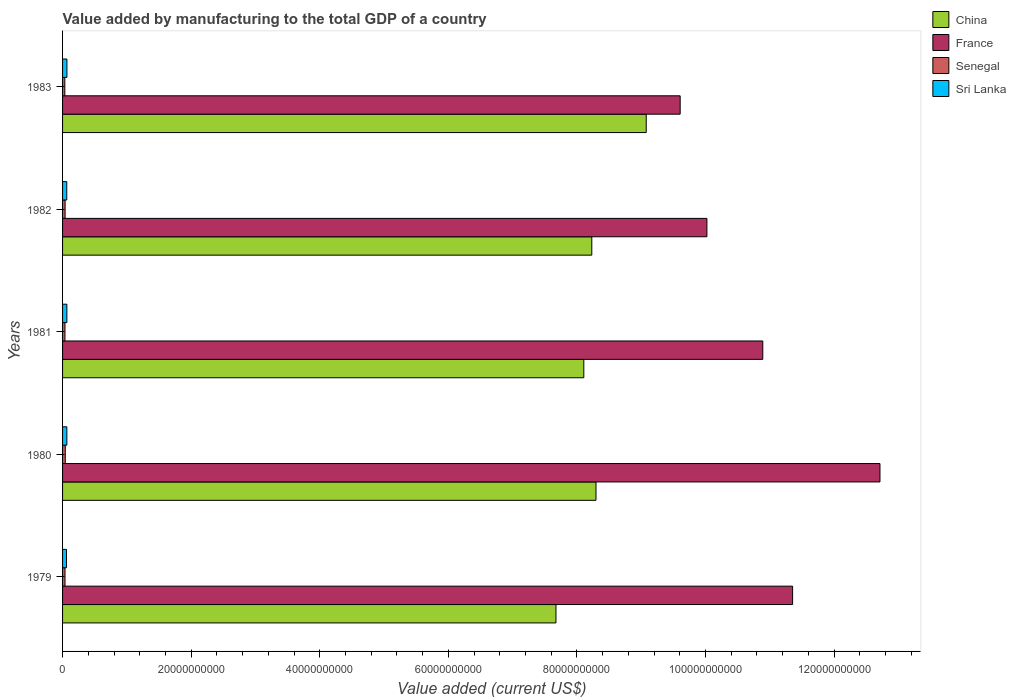How many different coloured bars are there?
Provide a short and direct response. 4. How many groups of bars are there?
Your answer should be very brief. 5. Are the number of bars per tick equal to the number of legend labels?
Make the answer very short. Yes. Are the number of bars on each tick of the Y-axis equal?
Your response must be concise. Yes. How many bars are there on the 5th tick from the top?
Offer a terse response. 4. How many bars are there on the 1st tick from the bottom?
Keep it short and to the point. 4. What is the label of the 2nd group of bars from the top?
Provide a short and direct response. 1982. What is the value added by manufacturing to the total GDP in Senegal in 1981?
Provide a succinct answer. 3.73e+08. Across all years, what is the maximum value added by manufacturing to the total GDP in Sri Lanka?
Ensure brevity in your answer.  6.78e+08. Across all years, what is the minimum value added by manufacturing to the total GDP in Senegal?
Your answer should be compact. 3.51e+08. In which year was the value added by manufacturing to the total GDP in France maximum?
Make the answer very short. 1980. What is the total value added by manufacturing to the total GDP in Sri Lanka in the graph?
Your answer should be compact. 3.28e+09. What is the difference between the value added by manufacturing to the total GDP in Senegal in 1979 and that in 1983?
Your response must be concise. 3.02e+07. What is the difference between the value added by manufacturing to the total GDP in Senegal in 1981 and the value added by manufacturing to the total GDP in France in 1980?
Make the answer very short. -1.27e+11. What is the average value added by manufacturing to the total GDP in Sri Lanka per year?
Give a very brief answer. 6.56e+08. In the year 1980, what is the difference between the value added by manufacturing to the total GDP in Sri Lanka and value added by manufacturing to the total GDP in France?
Give a very brief answer. -1.26e+11. What is the ratio of the value added by manufacturing to the total GDP in Sri Lanka in 1979 to that in 1983?
Your response must be concise. 0.9. Is the difference between the value added by manufacturing to the total GDP in Sri Lanka in 1980 and 1981 greater than the difference between the value added by manufacturing to the total GDP in France in 1980 and 1981?
Keep it short and to the point. No. What is the difference between the highest and the second highest value added by manufacturing to the total GDP in Senegal?
Ensure brevity in your answer.  2.80e+07. What is the difference between the highest and the lowest value added by manufacturing to the total GDP in France?
Your answer should be compact. 3.11e+1. In how many years, is the value added by manufacturing to the total GDP in Senegal greater than the average value added by manufacturing to the total GDP in Senegal taken over all years?
Your answer should be compact. 2. What does the 4th bar from the bottom in 1981 represents?
Provide a succinct answer. Sri Lanka. How many bars are there?
Your answer should be compact. 20. Does the graph contain any zero values?
Provide a short and direct response. No. How are the legend labels stacked?
Keep it short and to the point. Vertical. What is the title of the graph?
Your answer should be compact. Value added by manufacturing to the total GDP of a country. Does "France" appear as one of the legend labels in the graph?
Keep it short and to the point. Yes. What is the label or title of the X-axis?
Offer a terse response. Value added (current US$). What is the label or title of the Y-axis?
Your answer should be very brief. Years. What is the Value added (current US$) in China in 1979?
Offer a very short reply. 7.67e+1. What is the Value added (current US$) in France in 1979?
Offer a terse response. 1.14e+11. What is the Value added (current US$) in Senegal in 1979?
Your response must be concise. 3.81e+08. What is the Value added (current US$) of Sri Lanka in 1979?
Offer a very short reply. 6.09e+08. What is the Value added (current US$) in China in 1980?
Ensure brevity in your answer.  8.30e+1. What is the Value added (current US$) in France in 1980?
Provide a short and direct response. 1.27e+11. What is the Value added (current US$) in Senegal in 1980?
Provide a short and direct response. 4.21e+08. What is the Value added (current US$) in Sri Lanka in 1980?
Ensure brevity in your answer.  6.68e+08. What is the Value added (current US$) in China in 1981?
Provide a short and direct response. 8.11e+1. What is the Value added (current US$) in France in 1981?
Offer a very short reply. 1.09e+11. What is the Value added (current US$) of Senegal in 1981?
Give a very brief answer. 3.73e+08. What is the Value added (current US$) in Sri Lanka in 1981?
Your answer should be very brief. 6.69e+08. What is the Value added (current US$) of China in 1982?
Your response must be concise. 8.23e+1. What is the Value added (current US$) in France in 1982?
Your answer should be very brief. 1.00e+11. What is the Value added (current US$) of Senegal in 1982?
Your response must be concise. 3.93e+08. What is the Value added (current US$) of Sri Lanka in 1982?
Provide a short and direct response. 6.54e+08. What is the Value added (current US$) of China in 1983?
Ensure brevity in your answer.  9.08e+1. What is the Value added (current US$) in France in 1983?
Provide a succinct answer. 9.61e+1. What is the Value added (current US$) in Senegal in 1983?
Give a very brief answer. 3.51e+08. What is the Value added (current US$) in Sri Lanka in 1983?
Ensure brevity in your answer.  6.78e+08. Across all years, what is the maximum Value added (current US$) in China?
Offer a very short reply. 9.08e+1. Across all years, what is the maximum Value added (current US$) of France?
Give a very brief answer. 1.27e+11. Across all years, what is the maximum Value added (current US$) of Senegal?
Your answer should be very brief. 4.21e+08. Across all years, what is the maximum Value added (current US$) in Sri Lanka?
Give a very brief answer. 6.78e+08. Across all years, what is the minimum Value added (current US$) in China?
Your response must be concise. 7.67e+1. Across all years, what is the minimum Value added (current US$) in France?
Provide a succinct answer. 9.61e+1. Across all years, what is the minimum Value added (current US$) in Senegal?
Provide a succinct answer. 3.51e+08. Across all years, what is the minimum Value added (current US$) of Sri Lanka?
Make the answer very short. 6.09e+08. What is the total Value added (current US$) of China in the graph?
Provide a succinct answer. 4.14e+11. What is the total Value added (current US$) of France in the graph?
Your answer should be very brief. 5.46e+11. What is the total Value added (current US$) of Senegal in the graph?
Your answer should be very brief. 1.92e+09. What is the total Value added (current US$) of Sri Lanka in the graph?
Make the answer very short. 3.28e+09. What is the difference between the Value added (current US$) of China in 1979 and that in 1980?
Provide a short and direct response. -6.23e+09. What is the difference between the Value added (current US$) in France in 1979 and that in 1980?
Your answer should be very brief. -1.36e+1. What is the difference between the Value added (current US$) in Senegal in 1979 and that in 1980?
Make the answer very short. -4.01e+07. What is the difference between the Value added (current US$) of Sri Lanka in 1979 and that in 1980?
Offer a very short reply. -5.92e+07. What is the difference between the Value added (current US$) in China in 1979 and that in 1981?
Keep it short and to the point. -4.33e+09. What is the difference between the Value added (current US$) of France in 1979 and that in 1981?
Your answer should be very brief. 4.64e+09. What is the difference between the Value added (current US$) in Senegal in 1979 and that in 1981?
Give a very brief answer. 8.11e+06. What is the difference between the Value added (current US$) of Sri Lanka in 1979 and that in 1981?
Offer a very short reply. -6.01e+07. What is the difference between the Value added (current US$) of China in 1979 and that in 1982?
Offer a terse response. -5.57e+09. What is the difference between the Value added (current US$) in France in 1979 and that in 1982?
Offer a very short reply. 1.33e+1. What is the difference between the Value added (current US$) in Senegal in 1979 and that in 1982?
Make the answer very short. -1.21e+07. What is the difference between the Value added (current US$) of Sri Lanka in 1979 and that in 1982?
Ensure brevity in your answer.  -4.45e+07. What is the difference between the Value added (current US$) of China in 1979 and that in 1983?
Provide a short and direct response. -1.40e+1. What is the difference between the Value added (current US$) of France in 1979 and that in 1983?
Your answer should be compact. 1.75e+1. What is the difference between the Value added (current US$) in Senegal in 1979 and that in 1983?
Give a very brief answer. 3.02e+07. What is the difference between the Value added (current US$) in Sri Lanka in 1979 and that in 1983?
Give a very brief answer. -6.91e+07. What is the difference between the Value added (current US$) in China in 1980 and that in 1981?
Keep it short and to the point. 1.90e+09. What is the difference between the Value added (current US$) in France in 1980 and that in 1981?
Your response must be concise. 1.82e+1. What is the difference between the Value added (current US$) in Senegal in 1980 and that in 1981?
Offer a terse response. 4.82e+07. What is the difference between the Value added (current US$) in Sri Lanka in 1980 and that in 1981?
Your answer should be very brief. -8.86e+05. What is the difference between the Value added (current US$) of China in 1980 and that in 1982?
Your answer should be compact. 6.55e+08. What is the difference between the Value added (current US$) in France in 1980 and that in 1982?
Give a very brief answer. 2.69e+1. What is the difference between the Value added (current US$) of Senegal in 1980 and that in 1982?
Keep it short and to the point. 2.80e+07. What is the difference between the Value added (current US$) in Sri Lanka in 1980 and that in 1982?
Ensure brevity in your answer.  1.48e+07. What is the difference between the Value added (current US$) of China in 1980 and that in 1983?
Provide a succinct answer. -7.81e+09. What is the difference between the Value added (current US$) of France in 1980 and that in 1983?
Provide a short and direct response. 3.11e+1. What is the difference between the Value added (current US$) in Senegal in 1980 and that in 1983?
Your answer should be compact. 7.02e+07. What is the difference between the Value added (current US$) of Sri Lanka in 1980 and that in 1983?
Provide a short and direct response. -9.84e+06. What is the difference between the Value added (current US$) of China in 1981 and that in 1982?
Give a very brief answer. -1.24e+09. What is the difference between the Value added (current US$) of France in 1981 and that in 1982?
Your answer should be very brief. 8.69e+09. What is the difference between the Value added (current US$) in Senegal in 1981 and that in 1982?
Ensure brevity in your answer.  -2.02e+07. What is the difference between the Value added (current US$) of Sri Lanka in 1981 and that in 1982?
Offer a terse response. 1.57e+07. What is the difference between the Value added (current US$) in China in 1981 and that in 1983?
Your answer should be very brief. -9.71e+09. What is the difference between the Value added (current US$) in France in 1981 and that in 1983?
Offer a very short reply. 1.29e+1. What is the difference between the Value added (current US$) in Senegal in 1981 and that in 1983?
Provide a succinct answer. 2.20e+07. What is the difference between the Value added (current US$) of Sri Lanka in 1981 and that in 1983?
Offer a terse response. -8.95e+06. What is the difference between the Value added (current US$) in China in 1982 and that in 1983?
Make the answer very short. -8.47e+09. What is the difference between the Value added (current US$) of France in 1982 and that in 1983?
Provide a succinct answer. 4.16e+09. What is the difference between the Value added (current US$) in Senegal in 1982 and that in 1983?
Your response must be concise. 4.22e+07. What is the difference between the Value added (current US$) in Sri Lanka in 1982 and that in 1983?
Provide a succinct answer. -2.46e+07. What is the difference between the Value added (current US$) in China in 1979 and the Value added (current US$) in France in 1980?
Offer a very short reply. -5.04e+1. What is the difference between the Value added (current US$) in China in 1979 and the Value added (current US$) in Senegal in 1980?
Ensure brevity in your answer.  7.63e+1. What is the difference between the Value added (current US$) in China in 1979 and the Value added (current US$) in Sri Lanka in 1980?
Offer a terse response. 7.61e+1. What is the difference between the Value added (current US$) in France in 1979 and the Value added (current US$) in Senegal in 1980?
Ensure brevity in your answer.  1.13e+11. What is the difference between the Value added (current US$) of France in 1979 and the Value added (current US$) of Sri Lanka in 1980?
Provide a succinct answer. 1.13e+11. What is the difference between the Value added (current US$) in Senegal in 1979 and the Value added (current US$) in Sri Lanka in 1980?
Provide a short and direct response. -2.87e+08. What is the difference between the Value added (current US$) of China in 1979 and the Value added (current US$) of France in 1981?
Your answer should be very brief. -3.22e+1. What is the difference between the Value added (current US$) of China in 1979 and the Value added (current US$) of Senegal in 1981?
Ensure brevity in your answer.  7.64e+1. What is the difference between the Value added (current US$) of China in 1979 and the Value added (current US$) of Sri Lanka in 1981?
Make the answer very short. 7.61e+1. What is the difference between the Value added (current US$) in France in 1979 and the Value added (current US$) in Senegal in 1981?
Make the answer very short. 1.13e+11. What is the difference between the Value added (current US$) in France in 1979 and the Value added (current US$) in Sri Lanka in 1981?
Make the answer very short. 1.13e+11. What is the difference between the Value added (current US$) of Senegal in 1979 and the Value added (current US$) of Sri Lanka in 1981?
Keep it short and to the point. -2.88e+08. What is the difference between the Value added (current US$) of China in 1979 and the Value added (current US$) of France in 1982?
Your answer should be compact. -2.35e+1. What is the difference between the Value added (current US$) in China in 1979 and the Value added (current US$) in Senegal in 1982?
Ensure brevity in your answer.  7.64e+1. What is the difference between the Value added (current US$) of China in 1979 and the Value added (current US$) of Sri Lanka in 1982?
Your answer should be compact. 7.61e+1. What is the difference between the Value added (current US$) in France in 1979 and the Value added (current US$) in Senegal in 1982?
Your answer should be compact. 1.13e+11. What is the difference between the Value added (current US$) in France in 1979 and the Value added (current US$) in Sri Lanka in 1982?
Offer a very short reply. 1.13e+11. What is the difference between the Value added (current US$) in Senegal in 1979 and the Value added (current US$) in Sri Lanka in 1982?
Offer a terse response. -2.72e+08. What is the difference between the Value added (current US$) in China in 1979 and the Value added (current US$) in France in 1983?
Your response must be concise. -1.93e+1. What is the difference between the Value added (current US$) of China in 1979 and the Value added (current US$) of Senegal in 1983?
Offer a very short reply. 7.64e+1. What is the difference between the Value added (current US$) of China in 1979 and the Value added (current US$) of Sri Lanka in 1983?
Your answer should be compact. 7.61e+1. What is the difference between the Value added (current US$) in France in 1979 and the Value added (current US$) in Senegal in 1983?
Your answer should be compact. 1.13e+11. What is the difference between the Value added (current US$) of France in 1979 and the Value added (current US$) of Sri Lanka in 1983?
Provide a succinct answer. 1.13e+11. What is the difference between the Value added (current US$) in Senegal in 1979 and the Value added (current US$) in Sri Lanka in 1983?
Ensure brevity in your answer.  -2.97e+08. What is the difference between the Value added (current US$) in China in 1980 and the Value added (current US$) in France in 1981?
Offer a terse response. -2.59e+1. What is the difference between the Value added (current US$) in China in 1980 and the Value added (current US$) in Senegal in 1981?
Ensure brevity in your answer.  8.26e+1. What is the difference between the Value added (current US$) in China in 1980 and the Value added (current US$) in Sri Lanka in 1981?
Your answer should be compact. 8.23e+1. What is the difference between the Value added (current US$) in France in 1980 and the Value added (current US$) in Senegal in 1981?
Make the answer very short. 1.27e+11. What is the difference between the Value added (current US$) of France in 1980 and the Value added (current US$) of Sri Lanka in 1981?
Provide a succinct answer. 1.26e+11. What is the difference between the Value added (current US$) in Senegal in 1980 and the Value added (current US$) in Sri Lanka in 1981?
Your answer should be compact. -2.48e+08. What is the difference between the Value added (current US$) in China in 1980 and the Value added (current US$) in France in 1982?
Your response must be concise. -1.73e+1. What is the difference between the Value added (current US$) of China in 1980 and the Value added (current US$) of Senegal in 1982?
Your answer should be very brief. 8.26e+1. What is the difference between the Value added (current US$) of China in 1980 and the Value added (current US$) of Sri Lanka in 1982?
Make the answer very short. 8.23e+1. What is the difference between the Value added (current US$) of France in 1980 and the Value added (current US$) of Senegal in 1982?
Make the answer very short. 1.27e+11. What is the difference between the Value added (current US$) of France in 1980 and the Value added (current US$) of Sri Lanka in 1982?
Your answer should be very brief. 1.26e+11. What is the difference between the Value added (current US$) in Senegal in 1980 and the Value added (current US$) in Sri Lanka in 1982?
Ensure brevity in your answer.  -2.32e+08. What is the difference between the Value added (current US$) of China in 1980 and the Value added (current US$) of France in 1983?
Your answer should be compact. -1.31e+1. What is the difference between the Value added (current US$) in China in 1980 and the Value added (current US$) in Senegal in 1983?
Offer a very short reply. 8.26e+1. What is the difference between the Value added (current US$) of China in 1980 and the Value added (current US$) of Sri Lanka in 1983?
Offer a very short reply. 8.23e+1. What is the difference between the Value added (current US$) of France in 1980 and the Value added (current US$) of Senegal in 1983?
Provide a succinct answer. 1.27e+11. What is the difference between the Value added (current US$) in France in 1980 and the Value added (current US$) in Sri Lanka in 1983?
Give a very brief answer. 1.26e+11. What is the difference between the Value added (current US$) of Senegal in 1980 and the Value added (current US$) of Sri Lanka in 1983?
Provide a succinct answer. -2.57e+08. What is the difference between the Value added (current US$) in China in 1981 and the Value added (current US$) in France in 1982?
Keep it short and to the point. -1.91e+1. What is the difference between the Value added (current US$) of China in 1981 and the Value added (current US$) of Senegal in 1982?
Your answer should be compact. 8.07e+1. What is the difference between the Value added (current US$) of China in 1981 and the Value added (current US$) of Sri Lanka in 1982?
Your response must be concise. 8.04e+1. What is the difference between the Value added (current US$) of France in 1981 and the Value added (current US$) of Senegal in 1982?
Keep it short and to the point. 1.09e+11. What is the difference between the Value added (current US$) of France in 1981 and the Value added (current US$) of Sri Lanka in 1982?
Offer a very short reply. 1.08e+11. What is the difference between the Value added (current US$) in Senegal in 1981 and the Value added (current US$) in Sri Lanka in 1982?
Your response must be concise. -2.80e+08. What is the difference between the Value added (current US$) in China in 1981 and the Value added (current US$) in France in 1983?
Give a very brief answer. -1.50e+1. What is the difference between the Value added (current US$) of China in 1981 and the Value added (current US$) of Senegal in 1983?
Give a very brief answer. 8.07e+1. What is the difference between the Value added (current US$) of China in 1981 and the Value added (current US$) of Sri Lanka in 1983?
Offer a very short reply. 8.04e+1. What is the difference between the Value added (current US$) in France in 1981 and the Value added (current US$) in Senegal in 1983?
Give a very brief answer. 1.09e+11. What is the difference between the Value added (current US$) in France in 1981 and the Value added (current US$) in Sri Lanka in 1983?
Make the answer very short. 1.08e+11. What is the difference between the Value added (current US$) in Senegal in 1981 and the Value added (current US$) in Sri Lanka in 1983?
Your answer should be very brief. -3.05e+08. What is the difference between the Value added (current US$) in China in 1982 and the Value added (current US$) in France in 1983?
Ensure brevity in your answer.  -1.37e+1. What is the difference between the Value added (current US$) in China in 1982 and the Value added (current US$) in Senegal in 1983?
Provide a succinct answer. 8.20e+1. What is the difference between the Value added (current US$) of China in 1982 and the Value added (current US$) of Sri Lanka in 1983?
Offer a terse response. 8.16e+1. What is the difference between the Value added (current US$) of France in 1982 and the Value added (current US$) of Senegal in 1983?
Offer a very short reply. 9.99e+1. What is the difference between the Value added (current US$) of France in 1982 and the Value added (current US$) of Sri Lanka in 1983?
Provide a succinct answer. 9.96e+1. What is the difference between the Value added (current US$) in Senegal in 1982 and the Value added (current US$) in Sri Lanka in 1983?
Your answer should be very brief. -2.85e+08. What is the average Value added (current US$) in China per year?
Make the answer very short. 8.28e+1. What is the average Value added (current US$) of France per year?
Your response must be concise. 1.09e+11. What is the average Value added (current US$) in Senegal per year?
Keep it short and to the point. 3.84e+08. What is the average Value added (current US$) in Sri Lanka per year?
Provide a short and direct response. 6.56e+08. In the year 1979, what is the difference between the Value added (current US$) of China and Value added (current US$) of France?
Offer a very short reply. -3.68e+1. In the year 1979, what is the difference between the Value added (current US$) in China and Value added (current US$) in Senegal?
Offer a terse response. 7.64e+1. In the year 1979, what is the difference between the Value added (current US$) of China and Value added (current US$) of Sri Lanka?
Keep it short and to the point. 7.61e+1. In the year 1979, what is the difference between the Value added (current US$) of France and Value added (current US$) of Senegal?
Provide a succinct answer. 1.13e+11. In the year 1979, what is the difference between the Value added (current US$) in France and Value added (current US$) in Sri Lanka?
Keep it short and to the point. 1.13e+11. In the year 1979, what is the difference between the Value added (current US$) in Senegal and Value added (current US$) in Sri Lanka?
Offer a very short reply. -2.28e+08. In the year 1980, what is the difference between the Value added (current US$) in China and Value added (current US$) in France?
Offer a very short reply. -4.42e+1. In the year 1980, what is the difference between the Value added (current US$) in China and Value added (current US$) in Senegal?
Offer a terse response. 8.26e+1. In the year 1980, what is the difference between the Value added (current US$) in China and Value added (current US$) in Sri Lanka?
Your answer should be very brief. 8.23e+1. In the year 1980, what is the difference between the Value added (current US$) of France and Value added (current US$) of Senegal?
Provide a succinct answer. 1.27e+11. In the year 1980, what is the difference between the Value added (current US$) in France and Value added (current US$) in Sri Lanka?
Ensure brevity in your answer.  1.26e+11. In the year 1980, what is the difference between the Value added (current US$) in Senegal and Value added (current US$) in Sri Lanka?
Your response must be concise. -2.47e+08. In the year 1981, what is the difference between the Value added (current US$) of China and Value added (current US$) of France?
Your response must be concise. -2.78e+1. In the year 1981, what is the difference between the Value added (current US$) of China and Value added (current US$) of Senegal?
Give a very brief answer. 8.07e+1. In the year 1981, what is the difference between the Value added (current US$) in China and Value added (current US$) in Sri Lanka?
Give a very brief answer. 8.04e+1. In the year 1981, what is the difference between the Value added (current US$) of France and Value added (current US$) of Senegal?
Keep it short and to the point. 1.09e+11. In the year 1981, what is the difference between the Value added (current US$) of France and Value added (current US$) of Sri Lanka?
Offer a very short reply. 1.08e+11. In the year 1981, what is the difference between the Value added (current US$) in Senegal and Value added (current US$) in Sri Lanka?
Make the answer very short. -2.96e+08. In the year 1982, what is the difference between the Value added (current US$) in China and Value added (current US$) in France?
Provide a succinct answer. -1.79e+1. In the year 1982, what is the difference between the Value added (current US$) in China and Value added (current US$) in Senegal?
Your answer should be compact. 8.19e+1. In the year 1982, what is the difference between the Value added (current US$) of China and Value added (current US$) of Sri Lanka?
Your answer should be very brief. 8.17e+1. In the year 1982, what is the difference between the Value added (current US$) of France and Value added (current US$) of Senegal?
Give a very brief answer. 9.98e+1. In the year 1982, what is the difference between the Value added (current US$) of France and Value added (current US$) of Sri Lanka?
Provide a succinct answer. 9.96e+1. In the year 1982, what is the difference between the Value added (current US$) of Senegal and Value added (current US$) of Sri Lanka?
Offer a terse response. -2.60e+08. In the year 1983, what is the difference between the Value added (current US$) of China and Value added (current US$) of France?
Provide a short and direct response. -5.28e+09. In the year 1983, what is the difference between the Value added (current US$) of China and Value added (current US$) of Senegal?
Provide a short and direct response. 9.04e+1. In the year 1983, what is the difference between the Value added (current US$) in China and Value added (current US$) in Sri Lanka?
Your response must be concise. 9.01e+1. In the year 1983, what is the difference between the Value added (current US$) of France and Value added (current US$) of Senegal?
Ensure brevity in your answer.  9.57e+1. In the year 1983, what is the difference between the Value added (current US$) of France and Value added (current US$) of Sri Lanka?
Keep it short and to the point. 9.54e+1. In the year 1983, what is the difference between the Value added (current US$) of Senegal and Value added (current US$) of Sri Lanka?
Make the answer very short. -3.27e+08. What is the ratio of the Value added (current US$) in China in 1979 to that in 1980?
Ensure brevity in your answer.  0.92. What is the ratio of the Value added (current US$) in France in 1979 to that in 1980?
Make the answer very short. 0.89. What is the ratio of the Value added (current US$) in Senegal in 1979 to that in 1980?
Offer a terse response. 0.9. What is the ratio of the Value added (current US$) of Sri Lanka in 1979 to that in 1980?
Your response must be concise. 0.91. What is the ratio of the Value added (current US$) of China in 1979 to that in 1981?
Provide a succinct answer. 0.95. What is the ratio of the Value added (current US$) in France in 1979 to that in 1981?
Provide a succinct answer. 1.04. What is the ratio of the Value added (current US$) in Senegal in 1979 to that in 1981?
Your answer should be very brief. 1.02. What is the ratio of the Value added (current US$) of Sri Lanka in 1979 to that in 1981?
Keep it short and to the point. 0.91. What is the ratio of the Value added (current US$) of China in 1979 to that in 1982?
Give a very brief answer. 0.93. What is the ratio of the Value added (current US$) of France in 1979 to that in 1982?
Ensure brevity in your answer.  1.13. What is the ratio of the Value added (current US$) in Senegal in 1979 to that in 1982?
Provide a succinct answer. 0.97. What is the ratio of the Value added (current US$) in Sri Lanka in 1979 to that in 1982?
Make the answer very short. 0.93. What is the ratio of the Value added (current US$) of China in 1979 to that in 1983?
Offer a very short reply. 0.85. What is the ratio of the Value added (current US$) in France in 1979 to that in 1983?
Your response must be concise. 1.18. What is the ratio of the Value added (current US$) in Senegal in 1979 to that in 1983?
Provide a short and direct response. 1.09. What is the ratio of the Value added (current US$) in Sri Lanka in 1979 to that in 1983?
Offer a very short reply. 0.9. What is the ratio of the Value added (current US$) of China in 1980 to that in 1981?
Make the answer very short. 1.02. What is the ratio of the Value added (current US$) of France in 1980 to that in 1981?
Provide a succinct answer. 1.17. What is the ratio of the Value added (current US$) in Senegal in 1980 to that in 1981?
Offer a terse response. 1.13. What is the ratio of the Value added (current US$) of Sri Lanka in 1980 to that in 1981?
Ensure brevity in your answer.  1. What is the ratio of the Value added (current US$) in China in 1980 to that in 1982?
Provide a short and direct response. 1.01. What is the ratio of the Value added (current US$) in France in 1980 to that in 1982?
Offer a terse response. 1.27. What is the ratio of the Value added (current US$) in Senegal in 1980 to that in 1982?
Your response must be concise. 1.07. What is the ratio of the Value added (current US$) of Sri Lanka in 1980 to that in 1982?
Keep it short and to the point. 1.02. What is the ratio of the Value added (current US$) of China in 1980 to that in 1983?
Your response must be concise. 0.91. What is the ratio of the Value added (current US$) of France in 1980 to that in 1983?
Provide a succinct answer. 1.32. What is the ratio of the Value added (current US$) in Sri Lanka in 1980 to that in 1983?
Ensure brevity in your answer.  0.99. What is the ratio of the Value added (current US$) in China in 1981 to that in 1982?
Your answer should be compact. 0.98. What is the ratio of the Value added (current US$) in France in 1981 to that in 1982?
Give a very brief answer. 1.09. What is the ratio of the Value added (current US$) of Senegal in 1981 to that in 1982?
Give a very brief answer. 0.95. What is the ratio of the Value added (current US$) of Sri Lanka in 1981 to that in 1982?
Your answer should be very brief. 1.02. What is the ratio of the Value added (current US$) of China in 1981 to that in 1983?
Ensure brevity in your answer.  0.89. What is the ratio of the Value added (current US$) of France in 1981 to that in 1983?
Provide a short and direct response. 1.13. What is the ratio of the Value added (current US$) of Senegal in 1981 to that in 1983?
Give a very brief answer. 1.06. What is the ratio of the Value added (current US$) of China in 1982 to that in 1983?
Provide a short and direct response. 0.91. What is the ratio of the Value added (current US$) in France in 1982 to that in 1983?
Your response must be concise. 1.04. What is the ratio of the Value added (current US$) of Senegal in 1982 to that in 1983?
Offer a very short reply. 1.12. What is the ratio of the Value added (current US$) of Sri Lanka in 1982 to that in 1983?
Offer a very short reply. 0.96. What is the difference between the highest and the second highest Value added (current US$) in China?
Provide a succinct answer. 7.81e+09. What is the difference between the highest and the second highest Value added (current US$) in France?
Your response must be concise. 1.36e+1. What is the difference between the highest and the second highest Value added (current US$) of Senegal?
Ensure brevity in your answer.  2.80e+07. What is the difference between the highest and the second highest Value added (current US$) of Sri Lanka?
Your answer should be compact. 8.95e+06. What is the difference between the highest and the lowest Value added (current US$) of China?
Your answer should be very brief. 1.40e+1. What is the difference between the highest and the lowest Value added (current US$) of France?
Offer a terse response. 3.11e+1. What is the difference between the highest and the lowest Value added (current US$) in Senegal?
Give a very brief answer. 7.02e+07. What is the difference between the highest and the lowest Value added (current US$) in Sri Lanka?
Ensure brevity in your answer.  6.91e+07. 